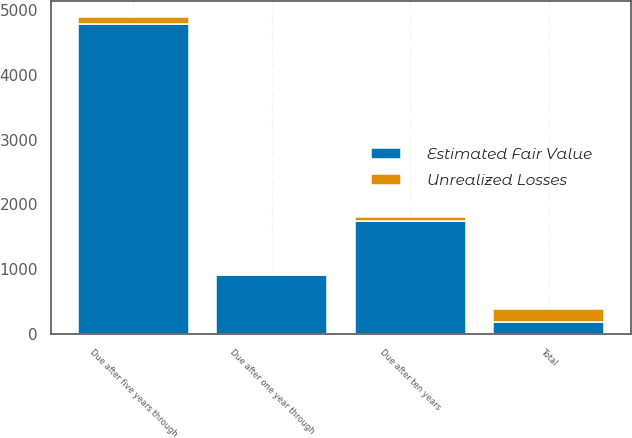<chart> <loc_0><loc_0><loc_500><loc_500><stacked_bar_chart><ecel><fcel>Due after one year through<fcel>Due after five years through<fcel>Due after ten years<fcel>Total<nl><fcel>Estimated Fair Value<fcel>909<fcel>4775<fcel>1739<fcel>192<nl><fcel>Unrealized Losses<fcel>12<fcel>109<fcel>69<fcel>192<nl></chart> 